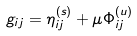Convert formula to latex. <formula><loc_0><loc_0><loc_500><loc_500>g _ { i j } = \eta ^ { ( s ) } _ { i j } + \mu \Phi _ { i j } ^ { ( u ) }</formula> 